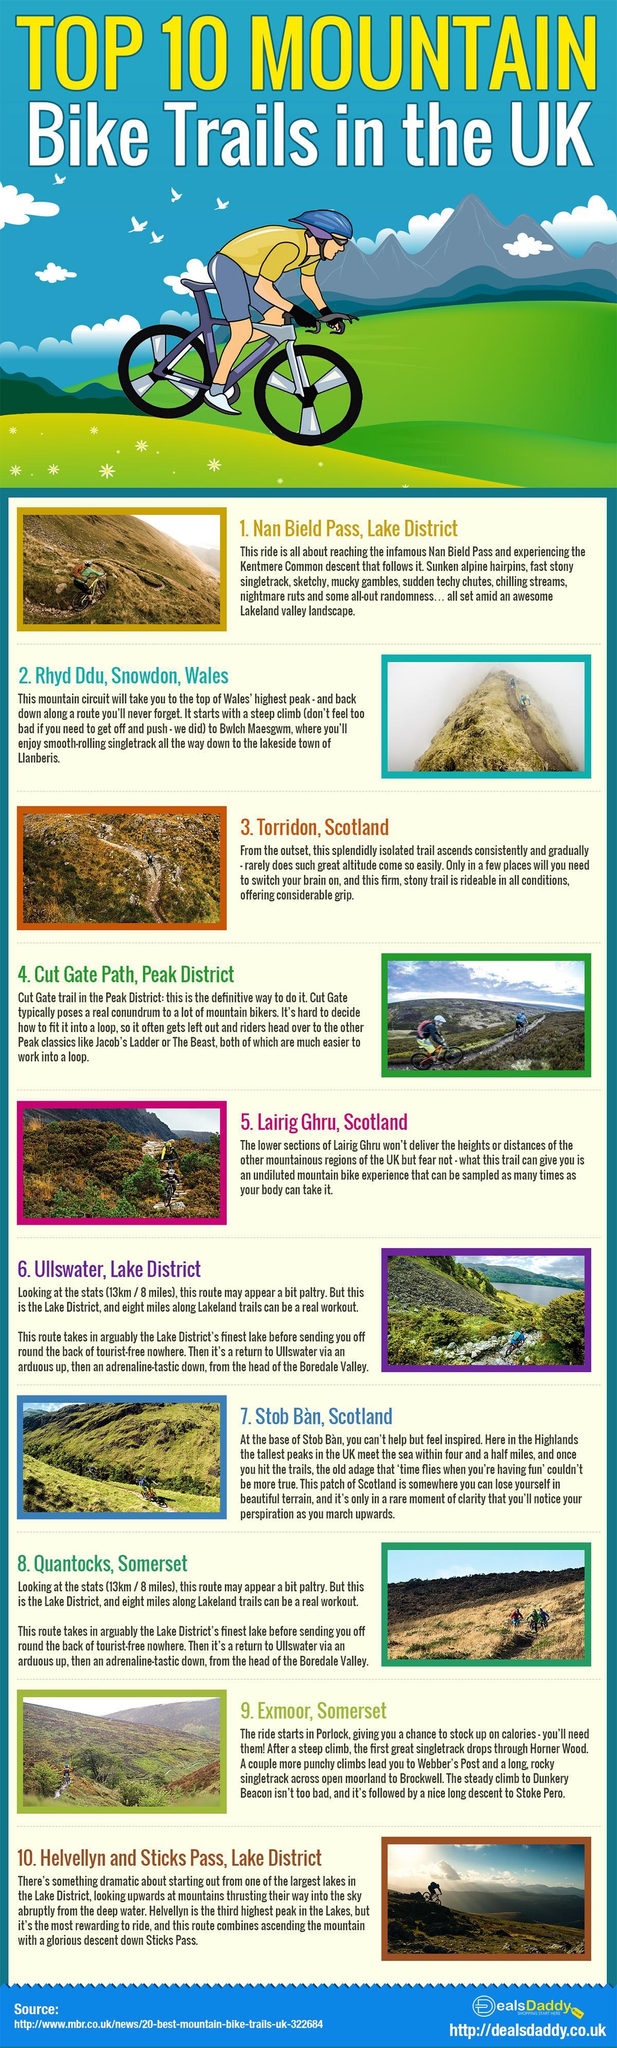Which mountain range provides an adrenaline-tastic down?
Answer the question with a short phrase. Ullswater, Lake District Which mountain provides a splendid bike experience in its trail? Lairig Ghru 